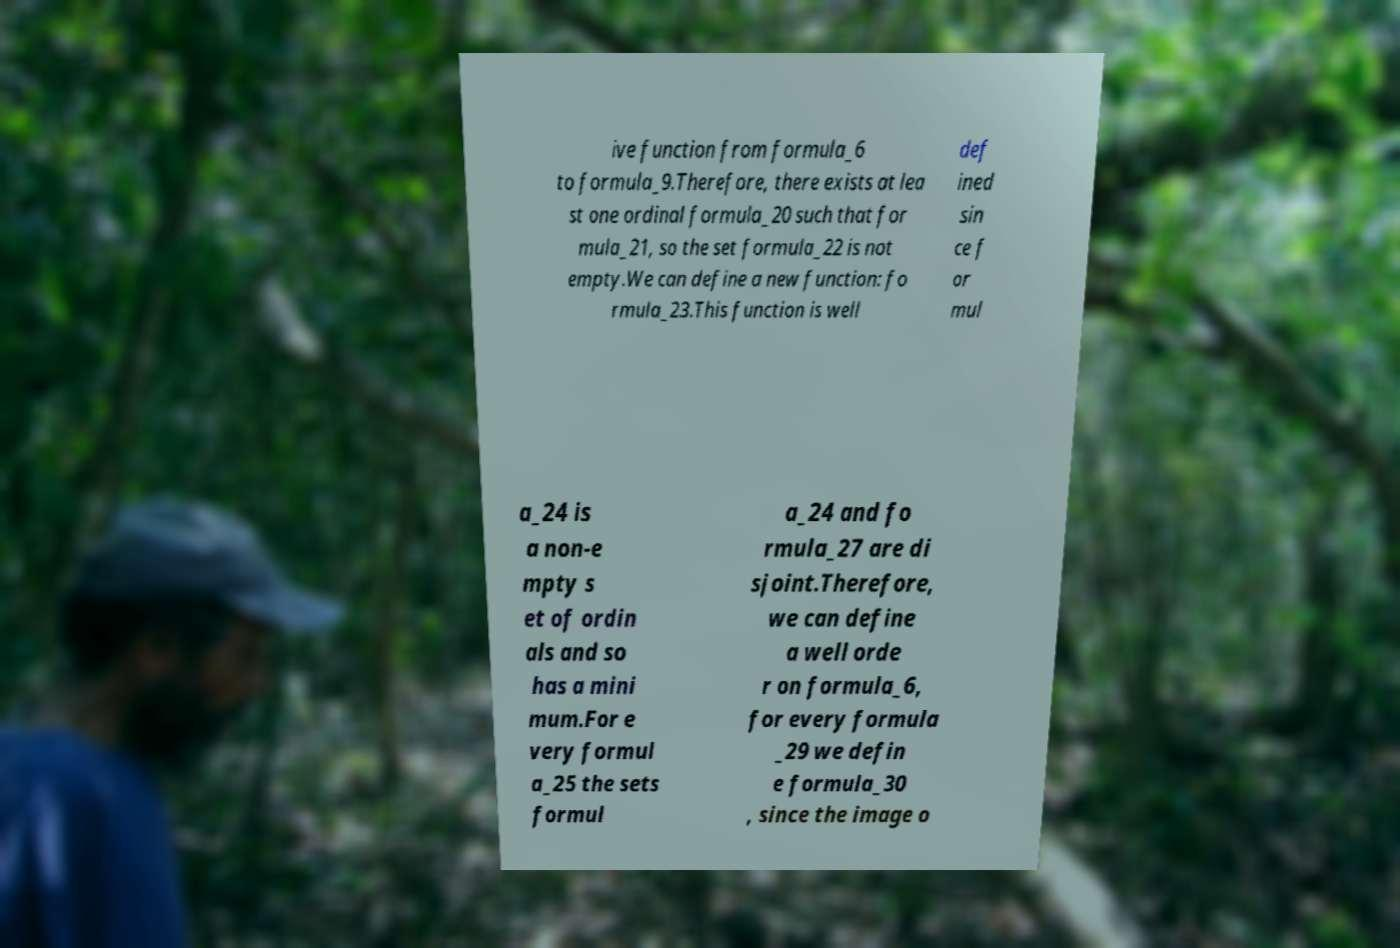For documentation purposes, I need the text within this image transcribed. Could you provide that? ive function from formula_6 to formula_9.Therefore, there exists at lea st one ordinal formula_20 such that for mula_21, so the set formula_22 is not empty.We can define a new function: fo rmula_23.This function is well def ined sin ce f or mul a_24 is a non-e mpty s et of ordin als and so has a mini mum.For e very formul a_25 the sets formul a_24 and fo rmula_27 are di sjoint.Therefore, we can define a well orde r on formula_6, for every formula _29 we defin e formula_30 , since the image o 